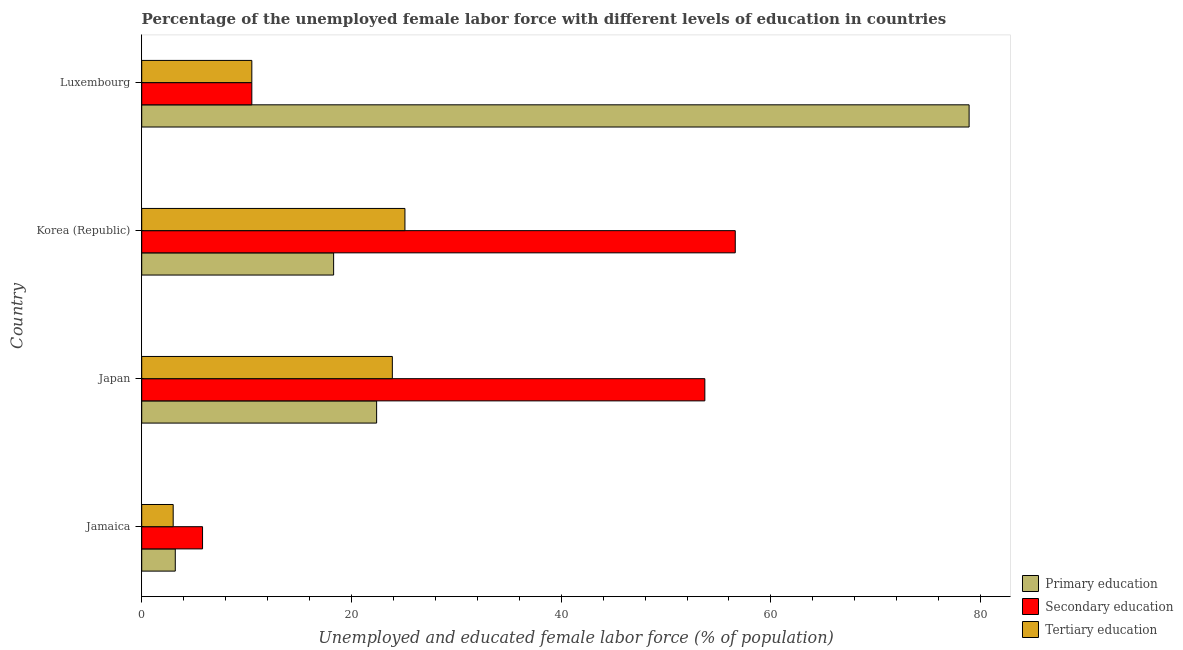Are the number of bars on each tick of the Y-axis equal?
Offer a terse response. Yes. How many bars are there on the 3rd tick from the top?
Provide a short and direct response. 3. How many bars are there on the 2nd tick from the bottom?
Provide a short and direct response. 3. What is the label of the 4th group of bars from the top?
Your response must be concise. Jamaica. In how many cases, is the number of bars for a given country not equal to the number of legend labels?
Offer a very short reply. 0. What is the percentage of female labor force who received secondary education in Jamaica?
Your answer should be compact. 5.8. Across all countries, what is the maximum percentage of female labor force who received tertiary education?
Make the answer very short. 25.1. Across all countries, what is the minimum percentage of female labor force who received secondary education?
Provide a short and direct response. 5.8. In which country was the percentage of female labor force who received secondary education minimum?
Your response must be concise. Jamaica. What is the total percentage of female labor force who received primary education in the graph?
Offer a terse response. 122.8. What is the difference between the percentage of female labor force who received secondary education in Korea (Republic) and that in Luxembourg?
Keep it short and to the point. 46.1. What is the difference between the percentage of female labor force who received secondary education in Korea (Republic) and the percentage of female labor force who received tertiary education in Jamaica?
Keep it short and to the point. 53.6. What is the average percentage of female labor force who received secondary education per country?
Offer a very short reply. 31.65. What is the ratio of the percentage of female labor force who received primary education in Korea (Republic) to that in Luxembourg?
Make the answer very short. 0.23. Is the percentage of female labor force who received secondary education in Jamaica less than that in Korea (Republic)?
Offer a very short reply. Yes. Is the difference between the percentage of female labor force who received primary education in Jamaica and Japan greater than the difference between the percentage of female labor force who received secondary education in Jamaica and Japan?
Keep it short and to the point. Yes. What is the difference between the highest and the second highest percentage of female labor force who received primary education?
Your answer should be compact. 56.5. What is the difference between the highest and the lowest percentage of female labor force who received secondary education?
Give a very brief answer. 50.8. In how many countries, is the percentage of female labor force who received secondary education greater than the average percentage of female labor force who received secondary education taken over all countries?
Your answer should be compact. 2. Is the sum of the percentage of female labor force who received secondary education in Jamaica and Luxembourg greater than the maximum percentage of female labor force who received tertiary education across all countries?
Your answer should be compact. No. What does the 1st bar from the top in Luxembourg represents?
Provide a short and direct response. Tertiary education. What does the 2nd bar from the bottom in Jamaica represents?
Make the answer very short. Secondary education. Is it the case that in every country, the sum of the percentage of female labor force who received primary education and percentage of female labor force who received secondary education is greater than the percentage of female labor force who received tertiary education?
Provide a succinct answer. Yes. How many countries are there in the graph?
Provide a short and direct response. 4. Are the values on the major ticks of X-axis written in scientific E-notation?
Provide a succinct answer. No. Where does the legend appear in the graph?
Offer a terse response. Bottom right. What is the title of the graph?
Your response must be concise. Percentage of the unemployed female labor force with different levels of education in countries. What is the label or title of the X-axis?
Your response must be concise. Unemployed and educated female labor force (% of population). What is the label or title of the Y-axis?
Your answer should be very brief. Country. What is the Unemployed and educated female labor force (% of population) in Primary education in Jamaica?
Offer a terse response. 3.2. What is the Unemployed and educated female labor force (% of population) in Secondary education in Jamaica?
Ensure brevity in your answer.  5.8. What is the Unemployed and educated female labor force (% of population) of Tertiary education in Jamaica?
Make the answer very short. 3. What is the Unemployed and educated female labor force (% of population) of Primary education in Japan?
Make the answer very short. 22.4. What is the Unemployed and educated female labor force (% of population) of Secondary education in Japan?
Ensure brevity in your answer.  53.7. What is the Unemployed and educated female labor force (% of population) in Tertiary education in Japan?
Your answer should be very brief. 23.9. What is the Unemployed and educated female labor force (% of population) of Primary education in Korea (Republic)?
Offer a terse response. 18.3. What is the Unemployed and educated female labor force (% of population) in Secondary education in Korea (Republic)?
Ensure brevity in your answer.  56.6. What is the Unemployed and educated female labor force (% of population) in Tertiary education in Korea (Republic)?
Offer a terse response. 25.1. What is the Unemployed and educated female labor force (% of population) in Primary education in Luxembourg?
Your response must be concise. 78.9. What is the Unemployed and educated female labor force (% of population) of Secondary education in Luxembourg?
Ensure brevity in your answer.  10.5. Across all countries, what is the maximum Unemployed and educated female labor force (% of population) of Primary education?
Give a very brief answer. 78.9. Across all countries, what is the maximum Unemployed and educated female labor force (% of population) in Secondary education?
Your answer should be very brief. 56.6. Across all countries, what is the maximum Unemployed and educated female labor force (% of population) of Tertiary education?
Provide a succinct answer. 25.1. Across all countries, what is the minimum Unemployed and educated female labor force (% of population) of Primary education?
Your answer should be compact. 3.2. Across all countries, what is the minimum Unemployed and educated female labor force (% of population) in Secondary education?
Your response must be concise. 5.8. What is the total Unemployed and educated female labor force (% of population) of Primary education in the graph?
Your response must be concise. 122.8. What is the total Unemployed and educated female labor force (% of population) of Secondary education in the graph?
Provide a short and direct response. 126.6. What is the total Unemployed and educated female labor force (% of population) of Tertiary education in the graph?
Your response must be concise. 62.5. What is the difference between the Unemployed and educated female labor force (% of population) of Primary education in Jamaica and that in Japan?
Ensure brevity in your answer.  -19.2. What is the difference between the Unemployed and educated female labor force (% of population) of Secondary education in Jamaica and that in Japan?
Provide a succinct answer. -47.9. What is the difference between the Unemployed and educated female labor force (% of population) of Tertiary education in Jamaica and that in Japan?
Keep it short and to the point. -20.9. What is the difference between the Unemployed and educated female labor force (% of population) of Primary education in Jamaica and that in Korea (Republic)?
Provide a short and direct response. -15.1. What is the difference between the Unemployed and educated female labor force (% of population) in Secondary education in Jamaica and that in Korea (Republic)?
Offer a very short reply. -50.8. What is the difference between the Unemployed and educated female labor force (% of population) in Tertiary education in Jamaica and that in Korea (Republic)?
Your response must be concise. -22.1. What is the difference between the Unemployed and educated female labor force (% of population) in Primary education in Jamaica and that in Luxembourg?
Your answer should be very brief. -75.7. What is the difference between the Unemployed and educated female labor force (% of population) in Secondary education in Jamaica and that in Luxembourg?
Give a very brief answer. -4.7. What is the difference between the Unemployed and educated female labor force (% of population) in Primary education in Japan and that in Luxembourg?
Your answer should be very brief. -56.5. What is the difference between the Unemployed and educated female labor force (% of population) in Secondary education in Japan and that in Luxembourg?
Your response must be concise. 43.2. What is the difference between the Unemployed and educated female labor force (% of population) in Tertiary education in Japan and that in Luxembourg?
Keep it short and to the point. 13.4. What is the difference between the Unemployed and educated female labor force (% of population) in Primary education in Korea (Republic) and that in Luxembourg?
Ensure brevity in your answer.  -60.6. What is the difference between the Unemployed and educated female labor force (% of population) of Secondary education in Korea (Republic) and that in Luxembourg?
Keep it short and to the point. 46.1. What is the difference between the Unemployed and educated female labor force (% of population) in Tertiary education in Korea (Republic) and that in Luxembourg?
Provide a succinct answer. 14.6. What is the difference between the Unemployed and educated female labor force (% of population) in Primary education in Jamaica and the Unemployed and educated female labor force (% of population) in Secondary education in Japan?
Provide a succinct answer. -50.5. What is the difference between the Unemployed and educated female labor force (% of population) in Primary education in Jamaica and the Unemployed and educated female labor force (% of population) in Tertiary education in Japan?
Give a very brief answer. -20.7. What is the difference between the Unemployed and educated female labor force (% of population) of Secondary education in Jamaica and the Unemployed and educated female labor force (% of population) of Tertiary education in Japan?
Offer a very short reply. -18.1. What is the difference between the Unemployed and educated female labor force (% of population) of Primary education in Jamaica and the Unemployed and educated female labor force (% of population) of Secondary education in Korea (Republic)?
Offer a terse response. -53.4. What is the difference between the Unemployed and educated female labor force (% of population) of Primary education in Jamaica and the Unemployed and educated female labor force (% of population) of Tertiary education in Korea (Republic)?
Your answer should be very brief. -21.9. What is the difference between the Unemployed and educated female labor force (% of population) of Secondary education in Jamaica and the Unemployed and educated female labor force (% of population) of Tertiary education in Korea (Republic)?
Your answer should be compact. -19.3. What is the difference between the Unemployed and educated female labor force (% of population) of Secondary education in Jamaica and the Unemployed and educated female labor force (% of population) of Tertiary education in Luxembourg?
Offer a very short reply. -4.7. What is the difference between the Unemployed and educated female labor force (% of population) in Primary education in Japan and the Unemployed and educated female labor force (% of population) in Secondary education in Korea (Republic)?
Your response must be concise. -34.2. What is the difference between the Unemployed and educated female labor force (% of population) in Primary education in Japan and the Unemployed and educated female labor force (% of population) in Tertiary education in Korea (Republic)?
Provide a short and direct response. -2.7. What is the difference between the Unemployed and educated female labor force (% of population) of Secondary education in Japan and the Unemployed and educated female labor force (% of population) of Tertiary education in Korea (Republic)?
Provide a succinct answer. 28.6. What is the difference between the Unemployed and educated female labor force (% of population) of Secondary education in Japan and the Unemployed and educated female labor force (% of population) of Tertiary education in Luxembourg?
Your response must be concise. 43.2. What is the difference between the Unemployed and educated female labor force (% of population) of Secondary education in Korea (Republic) and the Unemployed and educated female labor force (% of population) of Tertiary education in Luxembourg?
Your answer should be compact. 46.1. What is the average Unemployed and educated female labor force (% of population) of Primary education per country?
Your answer should be very brief. 30.7. What is the average Unemployed and educated female labor force (% of population) of Secondary education per country?
Give a very brief answer. 31.65. What is the average Unemployed and educated female labor force (% of population) of Tertiary education per country?
Give a very brief answer. 15.62. What is the difference between the Unemployed and educated female labor force (% of population) of Secondary education and Unemployed and educated female labor force (% of population) of Tertiary education in Jamaica?
Provide a succinct answer. 2.8. What is the difference between the Unemployed and educated female labor force (% of population) of Primary education and Unemployed and educated female labor force (% of population) of Secondary education in Japan?
Keep it short and to the point. -31.3. What is the difference between the Unemployed and educated female labor force (% of population) of Secondary education and Unemployed and educated female labor force (% of population) of Tertiary education in Japan?
Make the answer very short. 29.8. What is the difference between the Unemployed and educated female labor force (% of population) in Primary education and Unemployed and educated female labor force (% of population) in Secondary education in Korea (Republic)?
Offer a very short reply. -38.3. What is the difference between the Unemployed and educated female labor force (% of population) of Primary education and Unemployed and educated female labor force (% of population) of Tertiary education in Korea (Republic)?
Your response must be concise. -6.8. What is the difference between the Unemployed and educated female labor force (% of population) in Secondary education and Unemployed and educated female labor force (% of population) in Tertiary education in Korea (Republic)?
Provide a succinct answer. 31.5. What is the difference between the Unemployed and educated female labor force (% of population) in Primary education and Unemployed and educated female labor force (% of population) in Secondary education in Luxembourg?
Ensure brevity in your answer.  68.4. What is the difference between the Unemployed and educated female labor force (% of population) in Primary education and Unemployed and educated female labor force (% of population) in Tertiary education in Luxembourg?
Provide a succinct answer. 68.4. What is the difference between the Unemployed and educated female labor force (% of population) in Secondary education and Unemployed and educated female labor force (% of population) in Tertiary education in Luxembourg?
Your response must be concise. 0. What is the ratio of the Unemployed and educated female labor force (% of population) of Primary education in Jamaica to that in Japan?
Your response must be concise. 0.14. What is the ratio of the Unemployed and educated female labor force (% of population) in Secondary education in Jamaica to that in Japan?
Offer a terse response. 0.11. What is the ratio of the Unemployed and educated female labor force (% of population) of Tertiary education in Jamaica to that in Japan?
Your response must be concise. 0.13. What is the ratio of the Unemployed and educated female labor force (% of population) in Primary education in Jamaica to that in Korea (Republic)?
Keep it short and to the point. 0.17. What is the ratio of the Unemployed and educated female labor force (% of population) of Secondary education in Jamaica to that in Korea (Republic)?
Give a very brief answer. 0.1. What is the ratio of the Unemployed and educated female labor force (% of population) of Tertiary education in Jamaica to that in Korea (Republic)?
Ensure brevity in your answer.  0.12. What is the ratio of the Unemployed and educated female labor force (% of population) of Primary education in Jamaica to that in Luxembourg?
Provide a succinct answer. 0.04. What is the ratio of the Unemployed and educated female labor force (% of population) in Secondary education in Jamaica to that in Luxembourg?
Provide a short and direct response. 0.55. What is the ratio of the Unemployed and educated female labor force (% of population) of Tertiary education in Jamaica to that in Luxembourg?
Offer a terse response. 0.29. What is the ratio of the Unemployed and educated female labor force (% of population) in Primary education in Japan to that in Korea (Republic)?
Provide a short and direct response. 1.22. What is the ratio of the Unemployed and educated female labor force (% of population) of Secondary education in Japan to that in Korea (Republic)?
Keep it short and to the point. 0.95. What is the ratio of the Unemployed and educated female labor force (% of population) of Tertiary education in Japan to that in Korea (Republic)?
Ensure brevity in your answer.  0.95. What is the ratio of the Unemployed and educated female labor force (% of population) in Primary education in Japan to that in Luxembourg?
Offer a very short reply. 0.28. What is the ratio of the Unemployed and educated female labor force (% of population) in Secondary education in Japan to that in Luxembourg?
Provide a short and direct response. 5.11. What is the ratio of the Unemployed and educated female labor force (% of population) in Tertiary education in Japan to that in Luxembourg?
Keep it short and to the point. 2.28. What is the ratio of the Unemployed and educated female labor force (% of population) of Primary education in Korea (Republic) to that in Luxembourg?
Your response must be concise. 0.23. What is the ratio of the Unemployed and educated female labor force (% of population) in Secondary education in Korea (Republic) to that in Luxembourg?
Provide a short and direct response. 5.39. What is the ratio of the Unemployed and educated female labor force (% of population) in Tertiary education in Korea (Republic) to that in Luxembourg?
Provide a succinct answer. 2.39. What is the difference between the highest and the second highest Unemployed and educated female labor force (% of population) in Primary education?
Provide a succinct answer. 56.5. What is the difference between the highest and the second highest Unemployed and educated female labor force (% of population) in Secondary education?
Provide a succinct answer. 2.9. What is the difference between the highest and the second highest Unemployed and educated female labor force (% of population) in Tertiary education?
Offer a very short reply. 1.2. What is the difference between the highest and the lowest Unemployed and educated female labor force (% of population) in Primary education?
Offer a very short reply. 75.7. What is the difference between the highest and the lowest Unemployed and educated female labor force (% of population) in Secondary education?
Provide a short and direct response. 50.8. What is the difference between the highest and the lowest Unemployed and educated female labor force (% of population) of Tertiary education?
Ensure brevity in your answer.  22.1. 